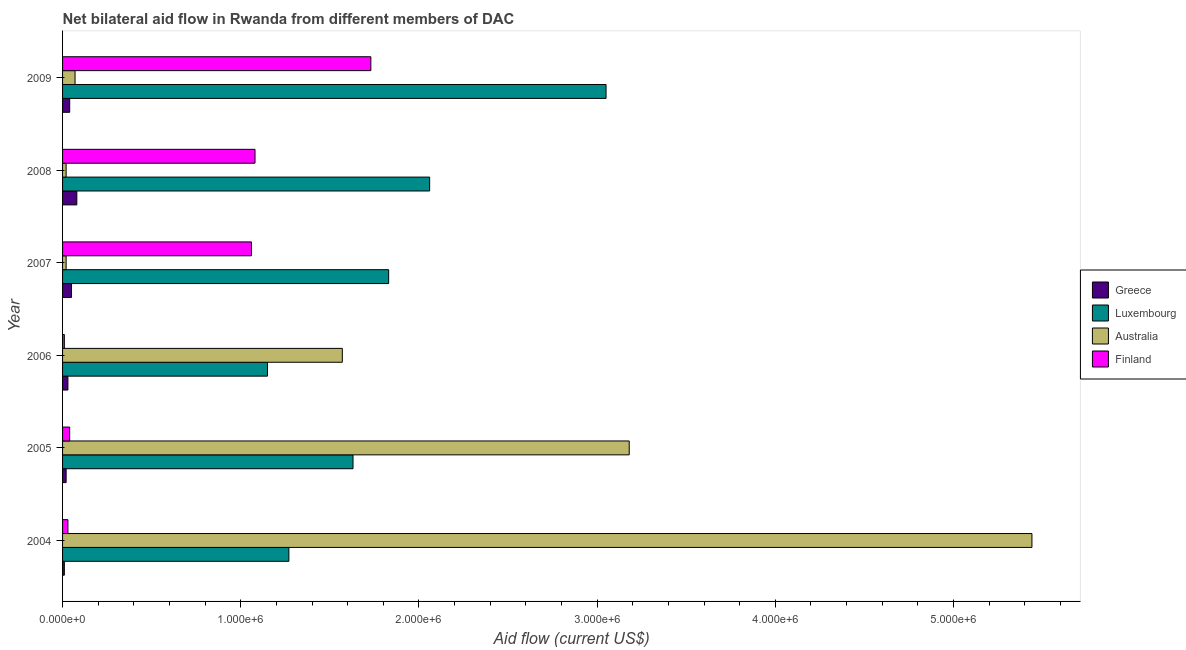How many groups of bars are there?
Give a very brief answer. 6. Are the number of bars per tick equal to the number of legend labels?
Make the answer very short. Yes. How many bars are there on the 1st tick from the bottom?
Provide a succinct answer. 4. In how many cases, is the number of bars for a given year not equal to the number of legend labels?
Keep it short and to the point. 0. What is the amount of aid given by australia in 2005?
Offer a very short reply. 3.18e+06. Across all years, what is the maximum amount of aid given by luxembourg?
Your answer should be compact. 3.05e+06. Across all years, what is the minimum amount of aid given by greece?
Make the answer very short. 10000. In which year was the amount of aid given by australia minimum?
Your answer should be very brief. 2007. What is the total amount of aid given by greece in the graph?
Give a very brief answer. 2.30e+05. What is the difference between the amount of aid given by australia in 2006 and that in 2009?
Offer a terse response. 1.50e+06. What is the difference between the amount of aid given by australia in 2005 and the amount of aid given by finland in 2009?
Make the answer very short. 1.45e+06. What is the average amount of aid given by australia per year?
Your answer should be very brief. 1.72e+06. In the year 2004, what is the difference between the amount of aid given by greece and amount of aid given by finland?
Your answer should be very brief. -2.00e+04. In how many years, is the amount of aid given by greece greater than 600000 US$?
Keep it short and to the point. 0. What is the ratio of the amount of aid given by greece in 2006 to that in 2008?
Keep it short and to the point. 0.38. What is the difference between the highest and the lowest amount of aid given by luxembourg?
Ensure brevity in your answer.  1.90e+06. In how many years, is the amount of aid given by luxembourg greater than the average amount of aid given by luxembourg taken over all years?
Make the answer very short. 2. Is the sum of the amount of aid given by finland in 2004 and 2009 greater than the maximum amount of aid given by australia across all years?
Your answer should be compact. No. What does the 4th bar from the top in 2009 represents?
Your answer should be compact. Greece. What does the 2nd bar from the bottom in 2005 represents?
Offer a terse response. Luxembourg. What is the difference between two consecutive major ticks on the X-axis?
Your answer should be very brief. 1.00e+06. Are the values on the major ticks of X-axis written in scientific E-notation?
Offer a terse response. Yes. Where does the legend appear in the graph?
Provide a succinct answer. Center right. How are the legend labels stacked?
Your answer should be compact. Vertical. What is the title of the graph?
Make the answer very short. Net bilateral aid flow in Rwanda from different members of DAC. Does "SF6 gas" appear as one of the legend labels in the graph?
Your answer should be very brief. No. What is the Aid flow (current US$) of Luxembourg in 2004?
Your response must be concise. 1.27e+06. What is the Aid flow (current US$) of Australia in 2004?
Give a very brief answer. 5.44e+06. What is the Aid flow (current US$) in Finland in 2004?
Offer a terse response. 3.00e+04. What is the Aid flow (current US$) of Greece in 2005?
Keep it short and to the point. 2.00e+04. What is the Aid flow (current US$) of Luxembourg in 2005?
Your response must be concise. 1.63e+06. What is the Aid flow (current US$) of Australia in 2005?
Offer a very short reply. 3.18e+06. What is the Aid flow (current US$) of Finland in 2005?
Offer a very short reply. 4.00e+04. What is the Aid flow (current US$) of Luxembourg in 2006?
Keep it short and to the point. 1.15e+06. What is the Aid flow (current US$) of Australia in 2006?
Keep it short and to the point. 1.57e+06. What is the Aid flow (current US$) in Finland in 2006?
Your answer should be compact. 10000. What is the Aid flow (current US$) of Greece in 2007?
Offer a very short reply. 5.00e+04. What is the Aid flow (current US$) of Luxembourg in 2007?
Your answer should be compact. 1.83e+06. What is the Aid flow (current US$) of Finland in 2007?
Keep it short and to the point. 1.06e+06. What is the Aid flow (current US$) in Greece in 2008?
Keep it short and to the point. 8.00e+04. What is the Aid flow (current US$) of Luxembourg in 2008?
Provide a succinct answer. 2.06e+06. What is the Aid flow (current US$) in Australia in 2008?
Keep it short and to the point. 2.00e+04. What is the Aid flow (current US$) in Finland in 2008?
Ensure brevity in your answer.  1.08e+06. What is the Aid flow (current US$) in Greece in 2009?
Your answer should be very brief. 4.00e+04. What is the Aid flow (current US$) in Luxembourg in 2009?
Your answer should be compact. 3.05e+06. What is the Aid flow (current US$) of Finland in 2009?
Your answer should be very brief. 1.73e+06. Across all years, what is the maximum Aid flow (current US$) of Greece?
Your answer should be compact. 8.00e+04. Across all years, what is the maximum Aid flow (current US$) in Luxembourg?
Your answer should be compact. 3.05e+06. Across all years, what is the maximum Aid flow (current US$) of Australia?
Ensure brevity in your answer.  5.44e+06. Across all years, what is the maximum Aid flow (current US$) of Finland?
Your answer should be compact. 1.73e+06. Across all years, what is the minimum Aid flow (current US$) of Greece?
Your response must be concise. 10000. Across all years, what is the minimum Aid flow (current US$) of Luxembourg?
Ensure brevity in your answer.  1.15e+06. Across all years, what is the minimum Aid flow (current US$) of Australia?
Offer a terse response. 2.00e+04. Across all years, what is the minimum Aid flow (current US$) of Finland?
Keep it short and to the point. 10000. What is the total Aid flow (current US$) in Greece in the graph?
Offer a very short reply. 2.30e+05. What is the total Aid flow (current US$) of Luxembourg in the graph?
Provide a succinct answer. 1.10e+07. What is the total Aid flow (current US$) in Australia in the graph?
Offer a very short reply. 1.03e+07. What is the total Aid flow (current US$) of Finland in the graph?
Your response must be concise. 3.95e+06. What is the difference between the Aid flow (current US$) of Greece in 2004 and that in 2005?
Offer a very short reply. -10000. What is the difference between the Aid flow (current US$) in Luxembourg in 2004 and that in 2005?
Your answer should be compact. -3.60e+05. What is the difference between the Aid flow (current US$) of Australia in 2004 and that in 2005?
Provide a short and direct response. 2.26e+06. What is the difference between the Aid flow (current US$) of Greece in 2004 and that in 2006?
Ensure brevity in your answer.  -2.00e+04. What is the difference between the Aid flow (current US$) in Luxembourg in 2004 and that in 2006?
Provide a succinct answer. 1.20e+05. What is the difference between the Aid flow (current US$) of Australia in 2004 and that in 2006?
Your answer should be compact. 3.87e+06. What is the difference between the Aid flow (current US$) of Finland in 2004 and that in 2006?
Offer a very short reply. 2.00e+04. What is the difference between the Aid flow (current US$) of Luxembourg in 2004 and that in 2007?
Offer a very short reply. -5.60e+05. What is the difference between the Aid flow (current US$) in Australia in 2004 and that in 2007?
Make the answer very short. 5.42e+06. What is the difference between the Aid flow (current US$) of Finland in 2004 and that in 2007?
Your answer should be very brief. -1.03e+06. What is the difference between the Aid flow (current US$) of Luxembourg in 2004 and that in 2008?
Your answer should be compact. -7.90e+05. What is the difference between the Aid flow (current US$) in Australia in 2004 and that in 2008?
Provide a succinct answer. 5.42e+06. What is the difference between the Aid flow (current US$) in Finland in 2004 and that in 2008?
Offer a very short reply. -1.05e+06. What is the difference between the Aid flow (current US$) of Luxembourg in 2004 and that in 2009?
Your response must be concise. -1.78e+06. What is the difference between the Aid flow (current US$) in Australia in 2004 and that in 2009?
Offer a terse response. 5.37e+06. What is the difference between the Aid flow (current US$) in Finland in 2004 and that in 2009?
Your answer should be very brief. -1.70e+06. What is the difference between the Aid flow (current US$) in Australia in 2005 and that in 2006?
Offer a terse response. 1.61e+06. What is the difference between the Aid flow (current US$) in Greece in 2005 and that in 2007?
Your answer should be compact. -3.00e+04. What is the difference between the Aid flow (current US$) of Australia in 2005 and that in 2007?
Make the answer very short. 3.16e+06. What is the difference between the Aid flow (current US$) in Finland in 2005 and that in 2007?
Keep it short and to the point. -1.02e+06. What is the difference between the Aid flow (current US$) in Luxembourg in 2005 and that in 2008?
Keep it short and to the point. -4.30e+05. What is the difference between the Aid flow (current US$) of Australia in 2005 and that in 2008?
Your answer should be very brief. 3.16e+06. What is the difference between the Aid flow (current US$) in Finland in 2005 and that in 2008?
Give a very brief answer. -1.04e+06. What is the difference between the Aid flow (current US$) of Luxembourg in 2005 and that in 2009?
Provide a succinct answer. -1.42e+06. What is the difference between the Aid flow (current US$) in Australia in 2005 and that in 2009?
Ensure brevity in your answer.  3.11e+06. What is the difference between the Aid flow (current US$) in Finland in 2005 and that in 2009?
Make the answer very short. -1.69e+06. What is the difference between the Aid flow (current US$) of Greece in 2006 and that in 2007?
Make the answer very short. -2.00e+04. What is the difference between the Aid flow (current US$) of Luxembourg in 2006 and that in 2007?
Your answer should be compact. -6.80e+05. What is the difference between the Aid flow (current US$) in Australia in 2006 and that in 2007?
Keep it short and to the point. 1.55e+06. What is the difference between the Aid flow (current US$) of Finland in 2006 and that in 2007?
Offer a very short reply. -1.05e+06. What is the difference between the Aid flow (current US$) of Luxembourg in 2006 and that in 2008?
Offer a terse response. -9.10e+05. What is the difference between the Aid flow (current US$) in Australia in 2006 and that in 2008?
Keep it short and to the point. 1.55e+06. What is the difference between the Aid flow (current US$) in Finland in 2006 and that in 2008?
Your answer should be very brief. -1.07e+06. What is the difference between the Aid flow (current US$) of Luxembourg in 2006 and that in 2009?
Offer a very short reply. -1.90e+06. What is the difference between the Aid flow (current US$) in Australia in 2006 and that in 2009?
Give a very brief answer. 1.50e+06. What is the difference between the Aid flow (current US$) of Finland in 2006 and that in 2009?
Provide a succinct answer. -1.72e+06. What is the difference between the Aid flow (current US$) in Greece in 2007 and that in 2009?
Your response must be concise. 10000. What is the difference between the Aid flow (current US$) of Luxembourg in 2007 and that in 2009?
Offer a very short reply. -1.22e+06. What is the difference between the Aid flow (current US$) of Finland in 2007 and that in 2009?
Give a very brief answer. -6.70e+05. What is the difference between the Aid flow (current US$) of Luxembourg in 2008 and that in 2009?
Provide a short and direct response. -9.90e+05. What is the difference between the Aid flow (current US$) of Australia in 2008 and that in 2009?
Your answer should be compact. -5.00e+04. What is the difference between the Aid flow (current US$) of Finland in 2008 and that in 2009?
Offer a terse response. -6.50e+05. What is the difference between the Aid flow (current US$) in Greece in 2004 and the Aid flow (current US$) in Luxembourg in 2005?
Provide a succinct answer. -1.62e+06. What is the difference between the Aid flow (current US$) of Greece in 2004 and the Aid flow (current US$) of Australia in 2005?
Make the answer very short. -3.17e+06. What is the difference between the Aid flow (current US$) of Greece in 2004 and the Aid flow (current US$) of Finland in 2005?
Make the answer very short. -3.00e+04. What is the difference between the Aid flow (current US$) in Luxembourg in 2004 and the Aid flow (current US$) in Australia in 2005?
Provide a short and direct response. -1.91e+06. What is the difference between the Aid flow (current US$) in Luxembourg in 2004 and the Aid flow (current US$) in Finland in 2005?
Ensure brevity in your answer.  1.23e+06. What is the difference between the Aid flow (current US$) of Australia in 2004 and the Aid flow (current US$) of Finland in 2005?
Give a very brief answer. 5.40e+06. What is the difference between the Aid flow (current US$) in Greece in 2004 and the Aid flow (current US$) in Luxembourg in 2006?
Keep it short and to the point. -1.14e+06. What is the difference between the Aid flow (current US$) of Greece in 2004 and the Aid flow (current US$) of Australia in 2006?
Ensure brevity in your answer.  -1.56e+06. What is the difference between the Aid flow (current US$) in Greece in 2004 and the Aid flow (current US$) in Finland in 2006?
Your answer should be very brief. 0. What is the difference between the Aid flow (current US$) in Luxembourg in 2004 and the Aid flow (current US$) in Finland in 2006?
Your answer should be very brief. 1.26e+06. What is the difference between the Aid flow (current US$) of Australia in 2004 and the Aid flow (current US$) of Finland in 2006?
Provide a succinct answer. 5.43e+06. What is the difference between the Aid flow (current US$) in Greece in 2004 and the Aid flow (current US$) in Luxembourg in 2007?
Make the answer very short. -1.82e+06. What is the difference between the Aid flow (current US$) in Greece in 2004 and the Aid flow (current US$) in Australia in 2007?
Your answer should be compact. -10000. What is the difference between the Aid flow (current US$) in Greece in 2004 and the Aid flow (current US$) in Finland in 2007?
Provide a succinct answer. -1.05e+06. What is the difference between the Aid flow (current US$) of Luxembourg in 2004 and the Aid flow (current US$) of Australia in 2007?
Your response must be concise. 1.25e+06. What is the difference between the Aid flow (current US$) in Australia in 2004 and the Aid flow (current US$) in Finland in 2007?
Ensure brevity in your answer.  4.38e+06. What is the difference between the Aid flow (current US$) of Greece in 2004 and the Aid flow (current US$) of Luxembourg in 2008?
Offer a terse response. -2.05e+06. What is the difference between the Aid flow (current US$) of Greece in 2004 and the Aid flow (current US$) of Finland in 2008?
Ensure brevity in your answer.  -1.07e+06. What is the difference between the Aid flow (current US$) of Luxembourg in 2004 and the Aid flow (current US$) of Australia in 2008?
Provide a short and direct response. 1.25e+06. What is the difference between the Aid flow (current US$) in Australia in 2004 and the Aid flow (current US$) in Finland in 2008?
Make the answer very short. 4.36e+06. What is the difference between the Aid flow (current US$) in Greece in 2004 and the Aid flow (current US$) in Luxembourg in 2009?
Your answer should be very brief. -3.04e+06. What is the difference between the Aid flow (current US$) in Greece in 2004 and the Aid flow (current US$) in Australia in 2009?
Your response must be concise. -6.00e+04. What is the difference between the Aid flow (current US$) of Greece in 2004 and the Aid flow (current US$) of Finland in 2009?
Your answer should be very brief. -1.72e+06. What is the difference between the Aid flow (current US$) in Luxembourg in 2004 and the Aid flow (current US$) in Australia in 2009?
Offer a terse response. 1.20e+06. What is the difference between the Aid flow (current US$) in Luxembourg in 2004 and the Aid flow (current US$) in Finland in 2009?
Your response must be concise. -4.60e+05. What is the difference between the Aid flow (current US$) in Australia in 2004 and the Aid flow (current US$) in Finland in 2009?
Make the answer very short. 3.71e+06. What is the difference between the Aid flow (current US$) in Greece in 2005 and the Aid flow (current US$) in Luxembourg in 2006?
Your answer should be very brief. -1.13e+06. What is the difference between the Aid flow (current US$) of Greece in 2005 and the Aid flow (current US$) of Australia in 2006?
Ensure brevity in your answer.  -1.55e+06. What is the difference between the Aid flow (current US$) in Luxembourg in 2005 and the Aid flow (current US$) in Australia in 2006?
Provide a short and direct response. 6.00e+04. What is the difference between the Aid flow (current US$) in Luxembourg in 2005 and the Aid flow (current US$) in Finland in 2006?
Provide a succinct answer. 1.62e+06. What is the difference between the Aid flow (current US$) in Australia in 2005 and the Aid flow (current US$) in Finland in 2006?
Your response must be concise. 3.17e+06. What is the difference between the Aid flow (current US$) in Greece in 2005 and the Aid flow (current US$) in Luxembourg in 2007?
Your answer should be compact. -1.81e+06. What is the difference between the Aid flow (current US$) of Greece in 2005 and the Aid flow (current US$) of Australia in 2007?
Your response must be concise. 0. What is the difference between the Aid flow (current US$) in Greece in 2005 and the Aid flow (current US$) in Finland in 2007?
Ensure brevity in your answer.  -1.04e+06. What is the difference between the Aid flow (current US$) in Luxembourg in 2005 and the Aid flow (current US$) in Australia in 2007?
Offer a terse response. 1.61e+06. What is the difference between the Aid flow (current US$) of Luxembourg in 2005 and the Aid flow (current US$) of Finland in 2007?
Your answer should be compact. 5.70e+05. What is the difference between the Aid flow (current US$) of Australia in 2005 and the Aid flow (current US$) of Finland in 2007?
Offer a terse response. 2.12e+06. What is the difference between the Aid flow (current US$) in Greece in 2005 and the Aid flow (current US$) in Luxembourg in 2008?
Offer a terse response. -2.04e+06. What is the difference between the Aid flow (current US$) of Greece in 2005 and the Aid flow (current US$) of Australia in 2008?
Your answer should be very brief. 0. What is the difference between the Aid flow (current US$) in Greece in 2005 and the Aid flow (current US$) in Finland in 2008?
Offer a terse response. -1.06e+06. What is the difference between the Aid flow (current US$) of Luxembourg in 2005 and the Aid flow (current US$) of Australia in 2008?
Keep it short and to the point. 1.61e+06. What is the difference between the Aid flow (current US$) in Luxembourg in 2005 and the Aid flow (current US$) in Finland in 2008?
Provide a succinct answer. 5.50e+05. What is the difference between the Aid flow (current US$) in Australia in 2005 and the Aid flow (current US$) in Finland in 2008?
Ensure brevity in your answer.  2.10e+06. What is the difference between the Aid flow (current US$) in Greece in 2005 and the Aid flow (current US$) in Luxembourg in 2009?
Your answer should be very brief. -3.03e+06. What is the difference between the Aid flow (current US$) of Greece in 2005 and the Aid flow (current US$) of Australia in 2009?
Ensure brevity in your answer.  -5.00e+04. What is the difference between the Aid flow (current US$) of Greece in 2005 and the Aid flow (current US$) of Finland in 2009?
Your answer should be very brief. -1.71e+06. What is the difference between the Aid flow (current US$) in Luxembourg in 2005 and the Aid flow (current US$) in Australia in 2009?
Keep it short and to the point. 1.56e+06. What is the difference between the Aid flow (current US$) of Australia in 2005 and the Aid flow (current US$) of Finland in 2009?
Offer a terse response. 1.45e+06. What is the difference between the Aid flow (current US$) of Greece in 2006 and the Aid flow (current US$) of Luxembourg in 2007?
Offer a terse response. -1.80e+06. What is the difference between the Aid flow (current US$) of Greece in 2006 and the Aid flow (current US$) of Finland in 2007?
Offer a very short reply. -1.03e+06. What is the difference between the Aid flow (current US$) in Luxembourg in 2006 and the Aid flow (current US$) in Australia in 2007?
Offer a terse response. 1.13e+06. What is the difference between the Aid flow (current US$) in Australia in 2006 and the Aid flow (current US$) in Finland in 2007?
Give a very brief answer. 5.10e+05. What is the difference between the Aid flow (current US$) of Greece in 2006 and the Aid flow (current US$) of Luxembourg in 2008?
Ensure brevity in your answer.  -2.03e+06. What is the difference between the Aid flow (current US$) in Greece in 2006 and the Aid flow (current US$) in Finland in 2008?
Your answer should be very brief. -1.05e+06. What is the difference between the Aid flow (current US$) of Luxembourg in 2006 and the Aid flow (current US$) of Australia in 2008?
Give a very brief answer. 1.13e+06. What is the difference between the Aid flow (current US$) in Luxembourg in 2006 and the Aid flow (current US$) in Finland in 2008?
Your response must be concise. 7.00e+04. What is the difference between the Aid flow (current US$) in Greece in 2006 and the Aid flow (current US$) in Luxembourg in 2009?
Your answer should be compact. -3.02e+06. What is the difference between the Aid flow (current US$) in Greece in 2006 and the Aid flow (current US$) in Finland in 2009?
Your answer should be compact. -1.70e+06. What is the difference between the Aid flow (current US$) of Luxembourg in 2006 and the Aid flow (current US$) of Australia in 2009?
Provide a short and direct response. 1.08e+06. What is the difference between the Aid flow (current US$) of Luxembourg in 2006 and the Aid flow (current US$) of Finland in 2009?
Provide a succinct answer. -5.80e+05. What is the difference between the Aid flow (current US$) in Greece in 2007 and the Aid flow (current US$) in Luxembourg in 2008?
Ensure brevity in your answer.  -2.01e+06. What is the difference between the Aid flow (current US$) of Greece in 2007 and the Aid flow (current US$) of Finland in 2008?
Offer a terse response. -1.03e+06. What is the difference between the Aid flow (current US$) of Luxembourg in 2007 and the Aid flow (current US$) of Australia in 2008?
Offer a very short reply. 1.81e+06. What is the difference between the Aid flow (current US$) of Luxembourg in 2007 and the Aid flow (current US$) of Finland in 2008?
Offer a very short reply. 7.50e+05. What is the difference between the Aid flow (current US$) of Australia in 2007 and the Aid flow (current US$) of Finland in 2008?
Give a very brief answer. -1.06e+06. What is the difference between the Aid flow (current US$) of Greece in 2007 and the Aid flow (current US$) of Australia in 2009?
Provide a succinct answer. -2.00e+04. What is the difference between the Aid flow (current US$) in Greece in 2007 and the Aid flow (current US$) in Finland in 2009?
Keep it short and to the point. -1.68e+06. What is the difference between the Aid flow (current US$) in Luxembourg in 2007 and the Aid flow (current US$) in Australia in 2009?
Provide a succinct answer. 1.76e+06. What is the difference between the Aid flow (current US$) of Luxembourg in 2007 and the Aid flow (current US$) of Finland in 2009?
Keep it short and to the point. 1.00e+05. What is the difference between the Aid flow (current US$) of Australia in 2007 and the Aid flow (current US$) of Finland in 2009?
Ensure brevity in your answer.  -1.71e+06. What is the difference between the Aid flow (current US$) in Greece in 2008 and the Aid flow (current US$) in Luxembourg in 2009?
Offer a very short reply. -2.97e+06. What is the difference between the Aid flow (current US$) in Greece in 2008 and the Aid flow (current US$) in Finland in 2009?
Provide a succinct answer. -1.65e+06. What is the difference between the Aid flow (current US$) in Luxembourg in 2008 and the Aid flow (current US$) in Australia in 2009?
Give a very brief answer. 1.99e+06. What is the difference between the Aid flow (current US$) of Luxembourg in 2008 and the Aid flow (current US$) of Finland in 2009?
Your answer should be very brief. 3.30e+05. What is the difference between the Aid flow (current US$) in Australia in 2008 and the Aid flow (current US$) in Finland in 2009?
Provide a succinct answer. -1.71e+06. What is the average Aid flow (current US$) of Greece per year?
Your response must be concise. 3.83e+04. What is the average Aid flow (current US$) in Luxembourg per year?
Your response must be concise. 1.83e+06. What is the average Aid flow (current US$) in Australia per year?
Provide a succinct answer. 1.72e+06. What is the average Aid flow (current US$) in Finland per year?
Keep it short and to the point. 6.58e+05. In the year 2004, what is the difference between the Aid flow (current US$) in Greece and Aid flow (current US$) in Luxembourg?
Your answer should be very brief. -1.26e+06. In the year 2004, what is the difference between the Aid flow (current US$) in Greece and Aid flow (current US$) in Australia?
Provide a succinct answer. -5.43e+06. In the year 2004, what is the difference between the Aid flow (current US$) in Greece and Aid flow (current US$) in Finland?
Your answer should be compact. -2.00e+04. In the year 2004, what is the difference between the Aid flow (current US$) of Luxembourg and Aid flow (current US$) of Australia?
Your answer should be very brief. -4.17e+06. In the year 2004, what is the difference between the Aid flow (current US$) of Luxembourg and Aid flow (current US$) of Finland?
Provide a short and direct response. 1.24e+06. In the year 2004, what is the difference between the Aid flow (current US$) of Australia and Aid flow (current US$) of Finland?
Provide a short and direct response. 5.41e+06. In the year 2005, what is the difference between the Aid flow (current US$) in Greece and Aid flow (current US$) in Luxembourg?
Provide a succinct answer. -1.61e+06. In the year 2005, what is the difference between the Aid flow (current US$) in Greece and Aid flow (current US$) in Australia?
Your answer should be compact. -3.16e+06. In the year 2005, what is the difference between the Aid flow (current US$) in Luxembourg and Aid flow (current US$) in Australia?
Provide a short and direct response. -1.55e+06. In the year 2005, what is the difference between the Aid flow (current US$) of Luxembourg and Aid flow (current US$) of Finland?
Provide a succinct answer. 1.59e+06. In the year 2005, what is the difference between the Aid flow (current US$) of Australia and Aid flow (current US$) of Finland?
Ensure brevity in your answer.  3.14e+06. In the year 2006, what is the difference between the Aid flow (current US$) in Greece and Aid flow (current US$) in Luxembourg?
Make the answer very short. -1.12e+06. In the year 2006, what is the difference between the Aid flow (current US$) in Greece and Aid flow (current US$) in Australia?
Your answer should be compact. -1.54e+06. In the year 2006, what is the difference between the Aid flow (current US$) in Greece and Aid flow (current US$) in Finland?
Give a very brief answer. 2.00e+04. In the year 2006, what is the difference between the Aid flow (current US$) of Luxembourg and Aid flow (current US$) of Australia?
Provide a succinct answer. -4.20e+05. In the year 2006, what is the difference between the Aid flow (current US$) of Luxembourg and Aid flow (current US$) of Finland?
Offer a terse response. 1.14e+06. In the year 2006, what is the difference between the Aid flow (current US$) of Australia and Aid flow (current US$) of Finland?
Give a very brief answer. 1.56e+06. In the year 2007, what is the difference between the Aid flow (current US$) in Greece and Aid flow (current US$) in Luxembourg?
Ensure brevity in your answer.  -1.78e+06. In the year 2007, what is the difference between the Aid flow (current US$) in Greece and Aid flow (current US$) in Australia?
Ensure brevity in your answer.  3.00e+04. In the year 2007, what is the difference between the Aid flow (current US$) of Greece and Aid flow (current US$) of Finland?
Provide a short and direct response. -1.01e+06. In the year 2007, what is the difference between the Aid flow (current US$) of Luxembourg and Aid flow (current US$) of Australia?
Offer a terse response. 1.81e+06. In the year 2007, what is the difference between the Aid flow (current US$) of Luxembourg and Aid flow (current US$) of Finland?
Keep it short and to the point. 7.70e+05. In the year 2007, what is the difference between the Aid flow (current US$) of Australia and Aid flow (current US$) of Finland?
Your answer should be very brief. -1.04e+06. In the year 2008, what is the difference between the Aid flow (current US$) in Greece and Aid flow (current US$) in Luxembourg?
Give a very brief answer. -1.98e+06. In the year 2008, what is the difference between the Aid flow (current US$) in Greece and Aid flow (current US$) in Australia?
Offer a very short reply. 6.00e+04. In the year 2008, what is the difference between the Aid flow (current US$) in Greece and Aid flow (current US$) in Finland?
Your response must be concise. -1.00e+06. In the year 2008, what is the difference between the Aid flow (current US$) in Luxembourg and Aid flow (current US$) in Australia?
Make the answer very short. 2.04e+06. In the year 2008, what is the difference between the Aid flow (current US$) in Luxembourg and Aid flow (current US$) in Finland?
Offer a very short reply. 9.80e+05. In the year 2008, what is the difference between the Aid flow (current US$) of Australia and Aid flow (current US$) of Finland?
Offer a very short reply. -1.06e+06. In the year 2009, what is the difference between the Aid flow (current US$) in Greece and Aid flow (current US$) in Luxembourg?
Your answer should be very brief. -3.01e+06. In the year 2009, what is the difference between the Aid flow (current US$) of Greece and Aid flow (current US$) of Finland?
Offer a very short reply. -1.69e+06. In the year 2009, what is the difference between the Aid flow (current US$) of Luxembourg and Aid flow (current US$) of Australia?
Your answer should be compact. 2.98e+06. In the year 2009, what is the difference between the Aid flow (current US$) of Luxembourg and Aid flow (current US$) of Finland?
Give a very brief answer. 1.32e+06. In the year 2009, what is the difference between the Aid flow (current US$) in Australia and Aid flow (current US$) in Finland?
Keep it short and to the point. -1.66e+06. What is the ratio of the Aid flow (current US$) in Luxembourg in 2004 to that in 2005?
Give a very brief answer. 0.78. What is the ratio of the Aid flow (current US$) in Australia in 2004 to that in 2005?
Offer a terse response. 1.71. What is the ratio of the Aid flow (current US$) in Finland in 2004 to that in 2005?
Make the answer very short. 0.75. What is the ratio of the Aid flow (current US$) of Greece in 2004 to that in 2006?
Ensure brevity in your answer.  0.33. What is the ratio of the Aid flow (current US$) in Luxembourg in 2004 to that in 2006?
Ensure brevity in your answer.  1.1. What is the ratio of the Aid flow (current US$) in Australia in 2004 to that in 2006?
Your answer should be very brief. 3.46. What is the ratio of the Aid flow (current US$) of Finland in 2004 to that in 2006?
Your answer should be compact. 3. What is the ratio of the Aid flow (current US$) of Greece in 2004 to that in 2007?
Offer a terse response. 0.2. What is the ratio of the Aid flow (current US$) in Luxembourg in 2004 to that in 2007?
Offer a terse response. 0.69. What is the ratio of the Aid flow (current US$) in Australia in 2004 to that in 2007?
Give a very brief answer. 272. What is the ratio of the Aid flow (current US$) in Finland in 2004 to that in 2007?
Provide a succinct answer. 0.03. What is the ratio of the Aid flow (current US$) in Luxembourg in 2004 to that in 2008?
Your response must be concise. 0.62. What is the ratio of the Aid flow (current US$) of Australia in 2004 to that in 2008?
Ensure brevity in your answer.  272. What is the ratio of the Aid flow (current US$) of Finland in 2004 to that in 2008?
Provide a short and direct response. 0.03. What is the ratio of the Aid flow (current US$) in Greece in 2004 to that in 2009?
Ensure brevity in your answer.  0.25. What is the ratio of the Aid flow (current US$) of Luxembourg in 2004 to that in 2009?
Provide a short and direct response. 0.42. What is the ratio of the Aid flow (current US$) of Australia in 2004 to that in 2009?
Make the answer very short. 77.71. What is the ratio of the Aid flow (current US$) in Finland in 2004 to that in 2009?
Give a very brief answer. 0.02. What is the ratio of the Aid flow (current US$) in Luxembourg in 2005 to that in 2006?
Offer a very short reply. 1.42. What is the ratio of the Aid flow (current US$) in Australia in 2005 to that in 2006?
Give a very brief answer. 2.03. What is the ratio of the Aid flow (current US$) in Luxembourg in 2005 to that in 2007?
Your answer should be compact. 0.89. What is the ratio of the Aid flow (current US$) in Australia in 2005 to that in 2007?
Provide a succinct answer. 159. What is the ratio of the Aid flow (current US$) of Finland in 2005 to that in 2007?
Ensure brevity in your answer.  0.04. What is the ratio of the Aid flow (current US$) in Greece in 2005 to that in 2008?
Make the answer very short. 0.25. What is the ratio of the Aid flow (current US$) in Luxembourg in 2005 to that in 2008?
Provide a succinct answer. 0.79. What is the ratio of the Aid flow (current US$) of Australia in 2005 to that in 2008?
Offer a terse response. 159. What is the ratio of the Aid flow (current US$) of Finland in 2005 to that in 2008?
Provide a succinct answer. 0.04. What is the ratio of the Aid flow (current US$) in Luxembourg in 2005 to that in 2009?
Provide a short and direct response. 0.53. What is the ratio of the Aid flow (current US$) in Australia in 2005 to that in 2009?
Your answer should be very brief. 45.43. What is the ratio of the Aid flow (current US$) in Finland in 2005 to that in 2009?
Provide a succinct answer. 0.02. What is the ratio of the Aid flow (current US$) of Luxembourg in 2006 to that in 2007?
Offer a terse response. 0.63. What is the ratio of the Aid flow (current US$) of Australia in 2006 to that in 2007?
Provide a succinct answer. 78.5. What is the ratio of the Aid flow (current US$) in Finland in 2006 to that in 2007?
Ensure brevity in your answer.  0.01. What is the ratio of the Aid flow (current US$) of Luxembourg in 2006 to that in 2008?
Keep it short and to the point. 0.56. What is the ratio of the Aid flow (current US$) in Australia in 2006 to that in 2008?
Your answer should be compact. 78.5. What is the ratio of the Aid flow (current US$) of Finland in 2006 to that in 2008?
Give a very brief answer. 0.01. What is the ratio of the Aid flow (current US$) of Greece in 2006 to that in 2009?
Offer a terse response. 0.75. What is the ratio of the Aid flow (current US$) of Luxembourg in 2006 to that in 2009?
Your answer should be compact. 0.38. What is the ratio of the Aid flow (current US$) in Australia in 2006 to that in 2009?
Provide a succinct answer. 22.43. What is the ratio of the Aid flow (current US$) of Finland in 2006 to that in 2009?
Provide a short and direct response. 0.01. What is the ratio of the Aid flow (current US$) of Luxembourg in 2007 to that in 2008?
Offer a terse response. 0.89. What is the ratio of the Aid flow (current US$) in Finland in 2007 to that in 2008?
Ensure brevity in your answer.  0.98. What is the ratio of the Aid flow (current US$) of Luxembourg in 2007 to that in 2009?
Your answer should be very brief. 0.6. What is the ratio of the Aid flow (current US$) in Australia in 2007 to that in 2009?
Your answer should be very brief. 0.29. What is the ratio of the Aid flow (current US$) in Finland in 2007 to that in 2009?
Your answer should be very brief. 0.61. What is the ratio of the Aid flow (current US$) of Luxembourg in 2008 to that in 2009?
Make the answer very short. 0.68. What is the ratio of the Aid flow (current US$) of Australia in 2008 to that in 2009?
Provide a short and direct response. 0.29. What is the ratio of the Aid flow (current US$) of Finland in 2008 to that in 2009?
Keep it short and to the point. 0.62. What is the difference between the highest and the second highest Aid flow (current US$) of Greece?
Offer a very short reply. 3.00e+04. What is the difference between the highest and the second highest Aid flow (current US$) of Luxembourg?
Provide a succinct answer. 9.90e+05. What is the difference between the highest and the second highest Aid flow (current US$) of Australia?
Offer a terse response. 2.26e+06. What is the difference between the highest and the second highest Aid flow (current US$) in Finland?
Provide a short and direct response. 6.50e+05. What is the difference between the highest and the lowest Aid flow (current US$) of Greece?
Provide a short and direct response. 7.00e+04. What is the difference between the highest and the lowest Aid flow (current US$) in Luxembourg?
Your answer should be very brief. 1.90e+06. What is the difference between the highest and the lowest Aid flow (current US$) in Australia?
Keep it short and to the point. 5.42e+06. What is the difference between the highest and the lowest Aid flow (current US$) of Finland?
Offer a very short reply. 1.72e+06. 